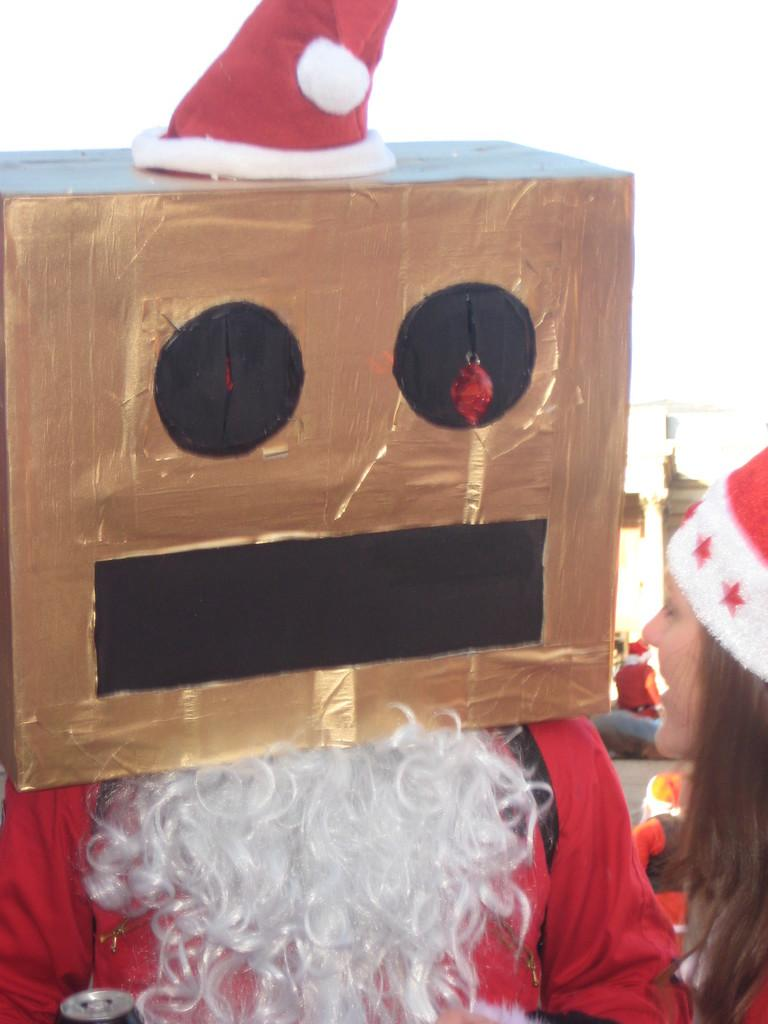What is the person in the image doing with the carton box? The person is covering their face with a carton box. What is the person wearing in the image? The person is wearing a Santa Claus dress. Who else is present in the image? There is a woman in the image. What is the woman wearing on her head? The woman is wearing a cap. What color is the sweater the person is wearing in the image? The person is not wearing a sweater in the image; they are wearing a Santa Claus dress. What type of crate is visible in the image? There is no crate present in the image. 